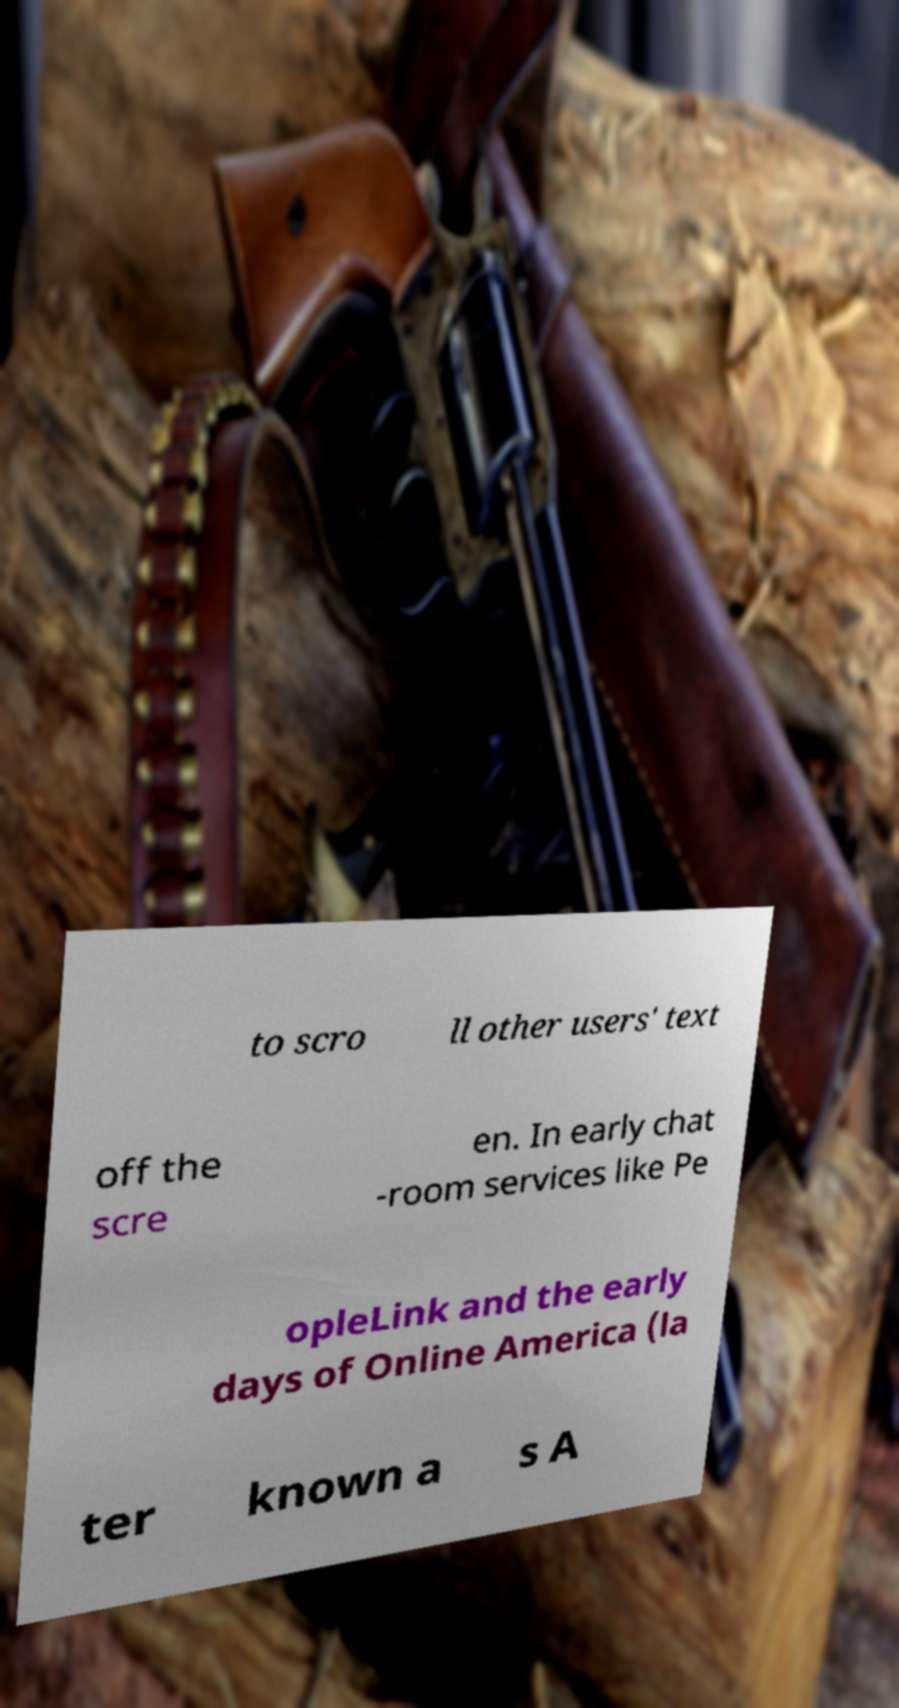Could you assist in decoding the text presented in this image and type it out clearly? to scro ll other users' text off the scre en. In early chat -room services like Pe opleLink and the early days of Online America (la ter known a s A 